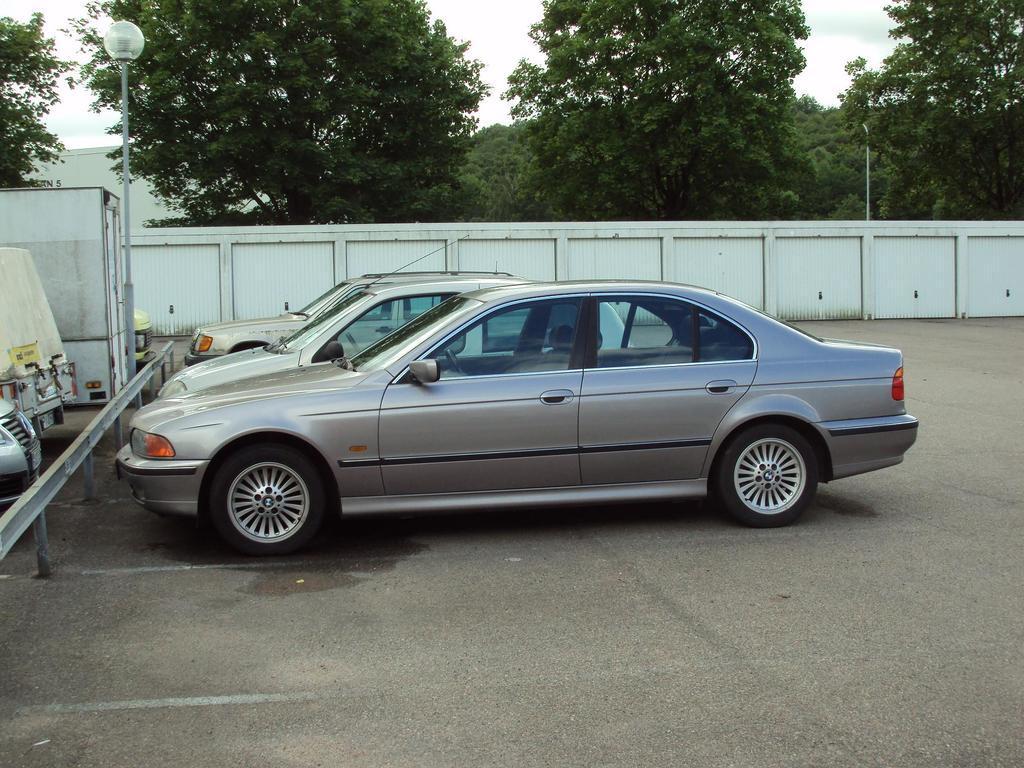How would you summarize this image in a sentence or two? In the middle of this image, there are three vehicles parked on a road. In front of them, there is a fence and there is a light attached to the pole. Besides this fence, there are other vehicles parked on the road. In the background, there is a white wall, there are trees, a pole, a building and sky. 